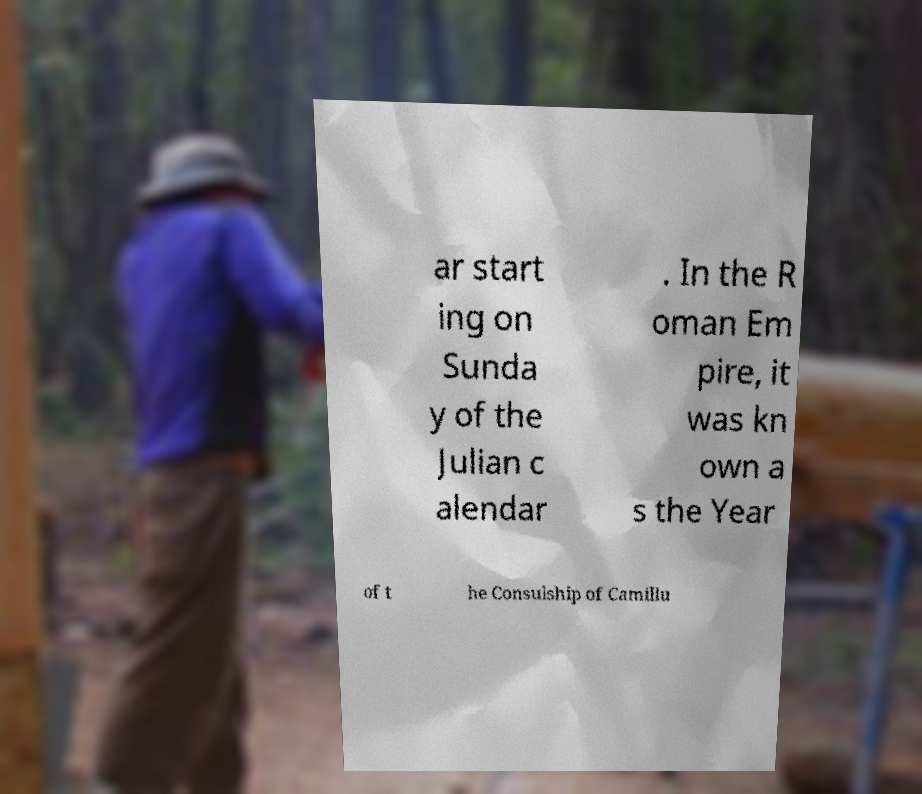Could you extract and type out the text from this image? ar start ing on Sunda y of the Julian c alendar . In the R oman Em pire, it was kn own a s the Year of t he Consulship of Camillu 